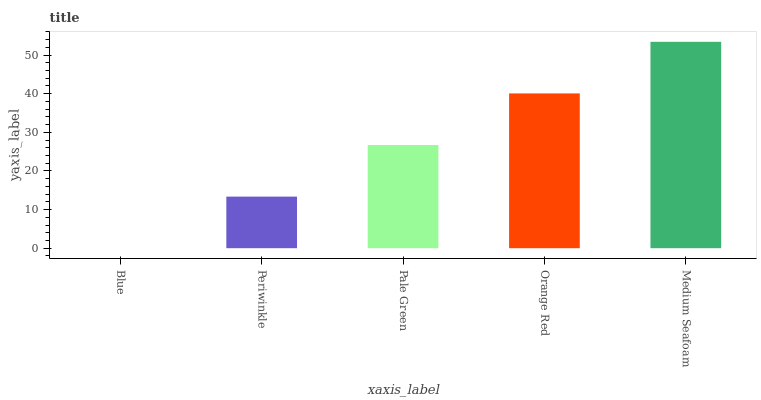Is Blue the minimum?
Answer yes or no. Yes. Is Medium Seafoam the maximum?
Answer yes or no. Yes. Is Periwinkle the minimum?
Answer yes or no. No. Is Periwinkle the maximum?
Answer yes or no. No. Is Periwinkle greater than Blue?
Answer yes or no. Yes. Is Blue less than Periwinkle?
Answer yes or no. Yes. Is Blue greater than Periwinkle?
Answer yes or no. No. Is Periwinkle less than Blue?
Answer yes or no. No. Is Pale Green the high median?
Answer yes or no. Yes. Is Pale Green the low median?
Answer yes or no. Yes. Is Medium Seafoam the high median?
Answer yes or no. No. Is Orange Red the low median?
Answer yes or no. No. 